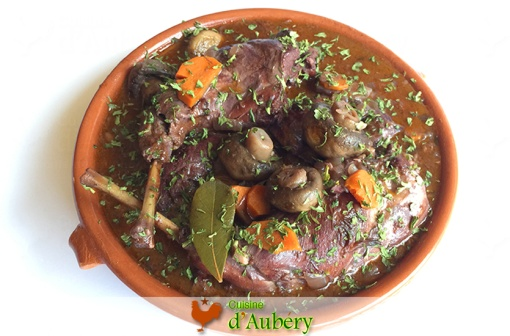What do you think is going on in this snapshot? This is an enticing image of a dish known as **Coq au Vin**, which is a classic French dish. The hearty meal appears in a circular terracotta dish set against a clean, white background. It features tender pieces of chicken, succulent mushrooms, and vibrant carrots, all bathed in a rich, dark sauce, hinting at the use of wine in its preparation. The dish is artfully garnished with finely chopped herbs, adding a fresh touch of green to its warm, comforting colors. Additionally, a bay leaf rests prominently atop the dish, signifying the final touch before serving. 